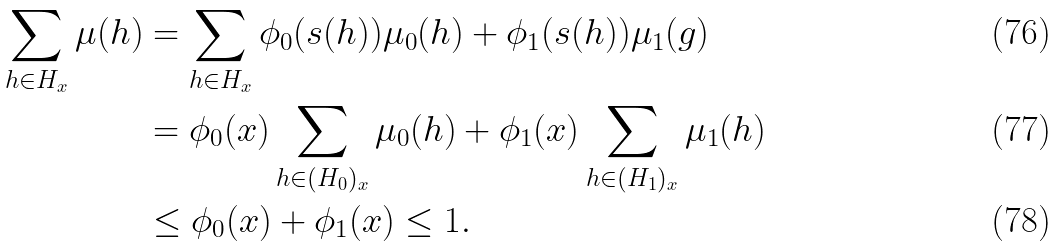Convert formula to latex. <formula><loc_0><loc_0><loc_500><loc_500>\sum _ { h \in H _ { x } } \mu ( h ) & = \sum _ { h \in H _ { x } } \phi _ { 0 } ( s ( h ) ) \mu _ { 0 } ( h ) + \phi _ { 1 } ( s ( h ) ) \mu _ { 1 } ( g ) \\ & = \phi _ { 0 } ( x ) \sum _ { h \in ( H _ { 0 } ) _ { x } } \mu _ { 0 } ( h ) + \phi _ { 1 } ( x ) \sum _ { h \in ( H _ { 1 } ) _ { x } } \mu _ { 1 } ( h ) \\ & \leq \phi _ { 0 } ( x ) + \phi _ { 1 } ( x ) \leq 1 .</formula> 